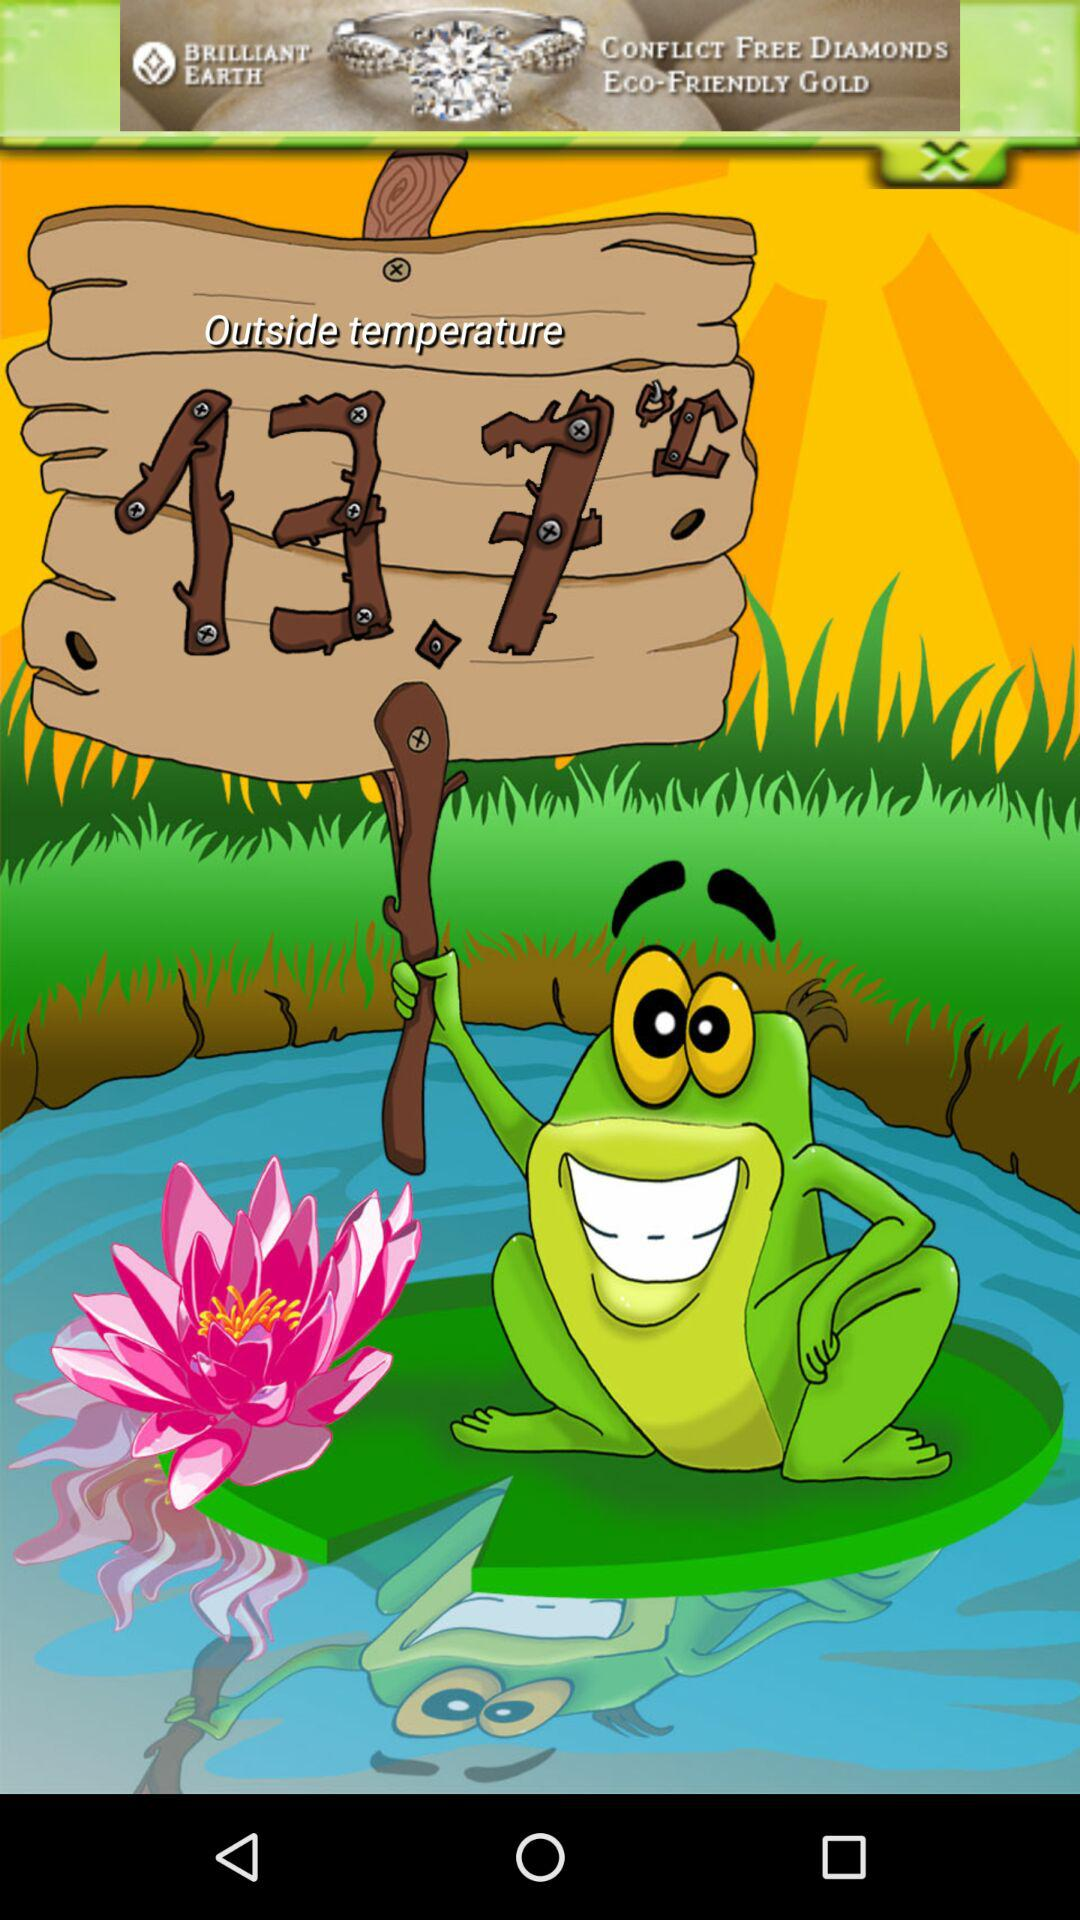Was yesterday's temperature the same as today's?
When the provided information is insufficient, respond with <no answer>. <no answer> 